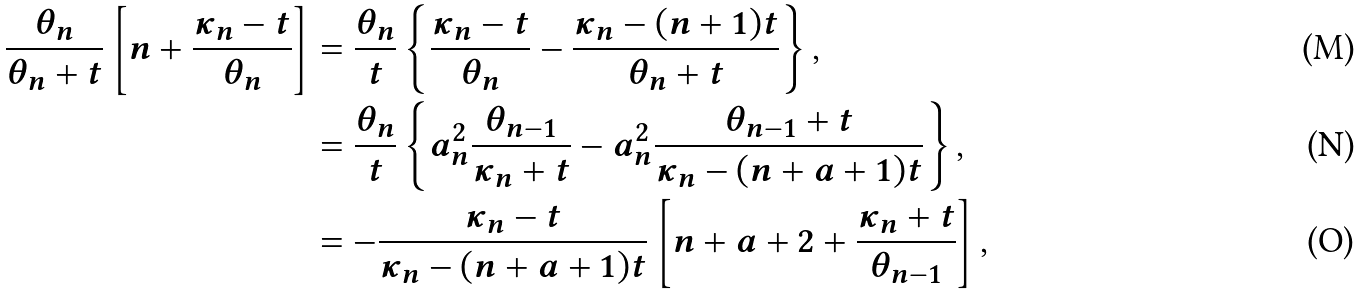<formula> <loc_0><loc_0><loc_500><loc_500>\frac { \theta _ { n } } { \theta _ { n } + t } \left [ n + \frac { \kappa _ { n } - t } { \theta _ { n } } \right ] & = \frac { \theta _ { n } } { t } \left \{ \frac { \kappa _ { n } - t } { \theta _ { n } } - \frac { \kappa _ { n } - ( n + 1 ) t } { \theta _ { n } + t } \right \} , \\ & = \frac { \theta _ { n } } { t } \left \{ a ^ { 2 } _ { n } \frac { \theta _ { n - 1 } } { \kappa _ { n } + t } - a ^ { 2 } _ { n } \frac { \theta _ { n - 1 } + t } { \kappa _ { n } - ( n + a + 1 ) t } \right \} , \\ & = - \frac { \kappa _ { n } - t } { \kappa _ { n } - ( n + a + 1 ) t } \left [ n + a + 2 + \frac { \kappa _ { n } + t } { \theta _ { n - 1 } } \right ] ,</formula> 